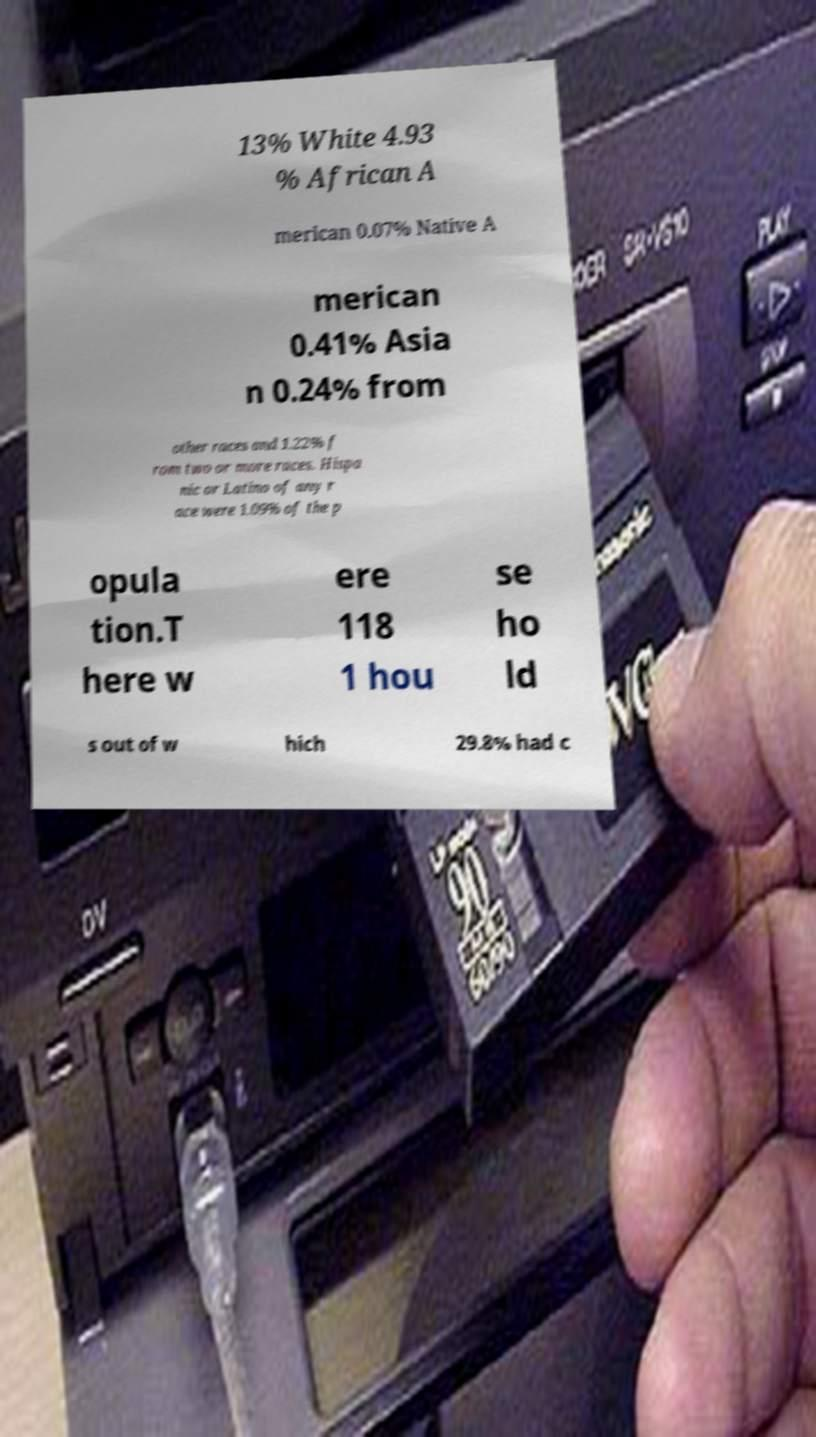What messages or text are displayed in this image? I need them in a readable, typed format. 13% White 4.93 % African A merican 0.07% Native A merican 0.41% Asia n 0.24% from other races and 1.22% f rom two or more races. Hispa nic or Latino of any r ace were 1.09% of the p opula tion.T here w ere 118 1 hou se ho ld s out of w hich 29.8% had c 